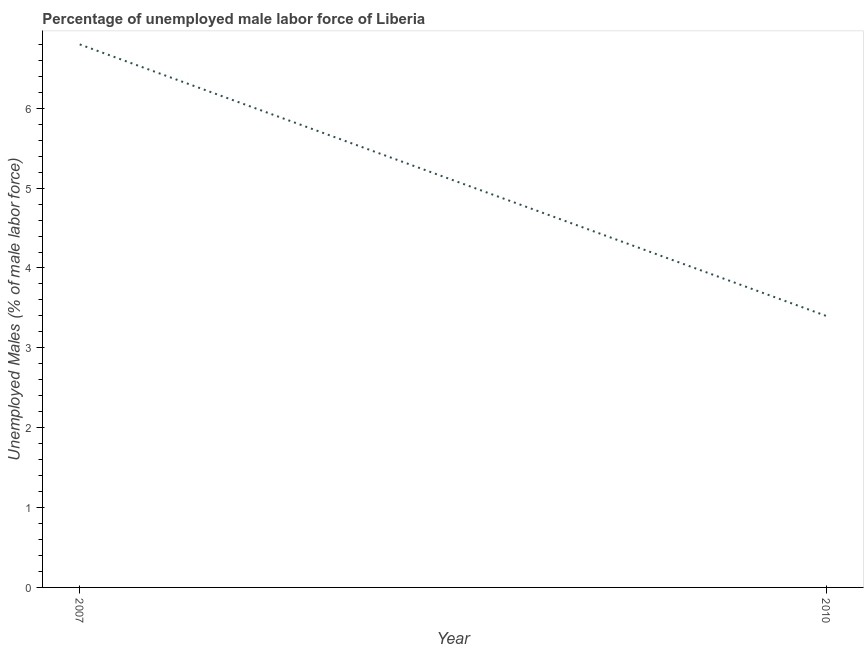What is the total unemployed male labour force in 2010?
Provide a short and direct response. 3.4. Across all years, what is the maximum total unemployed male labour force?
Your response must be concise. 6.8. Across all years, what is the minimum total unemployed male labour force?
Give a very brief answer. 3.4. What is the sum of the total unemployed male labour force?
Your answer should be compact. 10.2. What is the difference between the total unemployed male labour force in 2007 and 2010?
Provide a succinct answer. 3.4. What is the average total unemployed male labour force per year?
Your answer should be very brief. 5.1. What is the median total unemployed male labour force?
Your answer should be compact. 5.1. In how many years, is the total unemployed male labour force greater than 6 %?
Keep it short and to the point. 1. Do a majority of the years between 2010 and 2007 (inclusive) have total unemployed male labour force greater than 0.2 %?
Offer a terse response. No. What is the ratio of the total unemployed male labour force in 2007 to that in 2010?
Offer a terse response. 2. Is the total unemployed male labour force in 2007 less than that in 2010?
Offer a terse response. No. In how many years, is the total unemployed male labour force greater than the average total unemployed male labour force taken over all years?
Provide a succinct answer. 1. How many lines are there?
Your answer should be compact. 1. What is the difference between two consecutive major ticks on the Y-axis?
Keep it short and to the point. 1. What is the title of the graph?
Make the answer very short. Percentage of unemployed male labor force of Liberia. What is the label or title of the Y-axis?
Give a very brief answer. Unemployed Males (% of male labor force). What is the Unemployed Males (% of male labor force) in 2007?
Provide a short and direct response. 6.8. What is the Unemployed Males (% of male labor force) in 2010?
Provide a short and direct response. 3.4. 